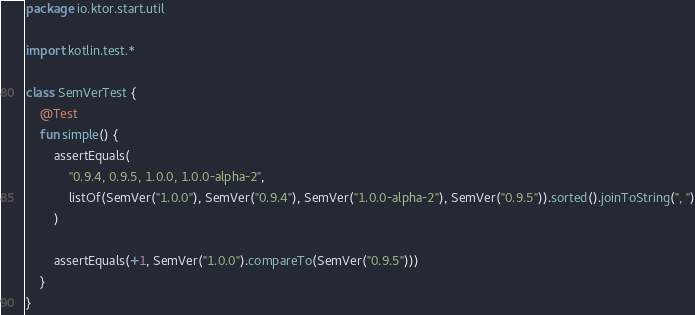Convert code to text. <code><loc_0><loc_0><loc_500><loc_500><_Kotlin_>package io.ktor.start.util

import kotlin.test.*

class SemVerTest {
    @Test
    fun simple() {
        assertEquals(
            "0.9.4, 0.9.5, 1.0.0, 1.0.0-alpha-2",
            listOf(SemVer("1.0.0"), SemVer("0.9.4"), SemVer("1.0.0-alpha-2"), SemVer("0.9.5")).sorted().joinToString(", ")
        )

        assertEquals(+1, SemVer("1.0.0").compareTo(SemVer("0.9.5")))
    }
}</code> 